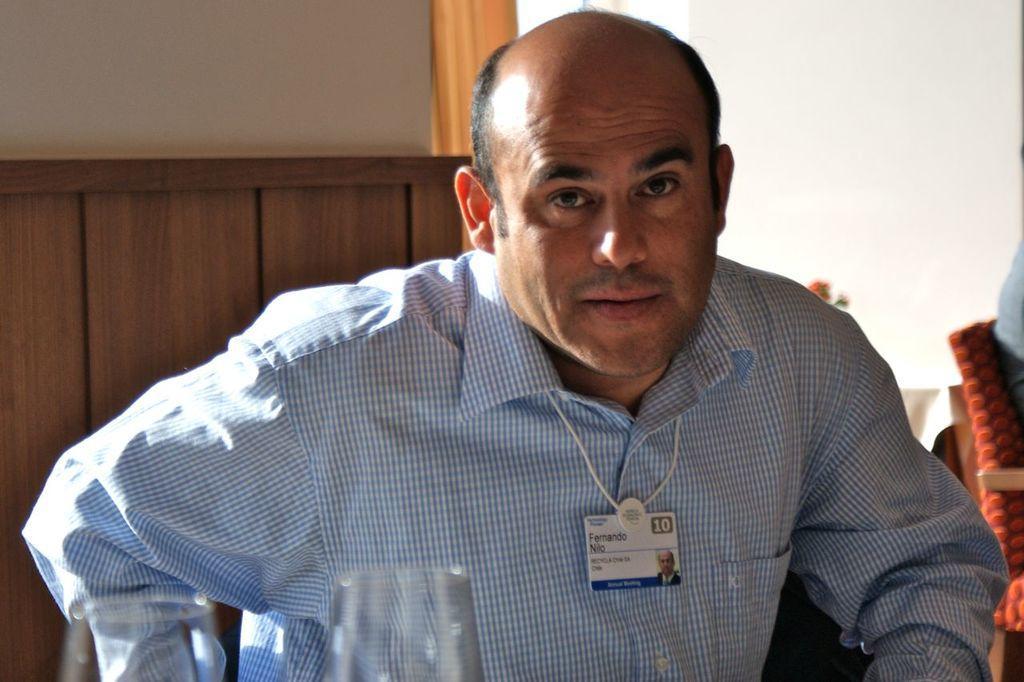Please provide a concise description of this image. Here we can see a man posing to a camera and he wore an id card. There are glasses and a chair. There is a white background. 